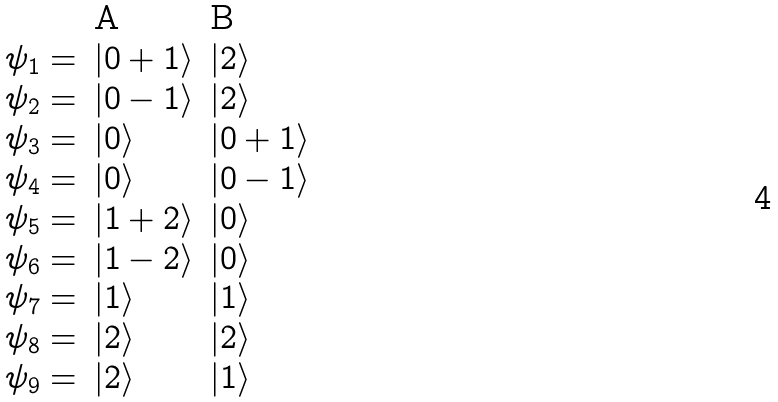<formula> <loc_0><loc_0><loc_500><loc_500>\begin{array} { l l l } \, & { \mbox A } \ & { \mbox B } \\ \psi _ { 1 } = & | 0 + 1 \rangle & | 2 \rangle \\ \psi _ { 2 } = & | 0 - 1 \rangle & | 2 \rangle \\ \psi _ { 3 } = & | 0 \rangle & | 0 + 1 \rangle \\ \psi _ { 4 } = & | 0 \rangle & | 0 - 1 \rangle \\ \psi _ { 5 } = & | 1 + 2 \rangle & | 0 \rangle \\ \psi _ { 6 } = & | 1 - 2 \rangle & | 0 \rangle \\ \psi _ { 7 } = & | 1 \rangle & | 1 \rangle \\ \psi _ { 8 } = & | 2 \rangle & | 2 \rangle \\ \psi _ { 9 } = & | 2 \rangle & | 1 \rangle \\ \end{array}</formula> 